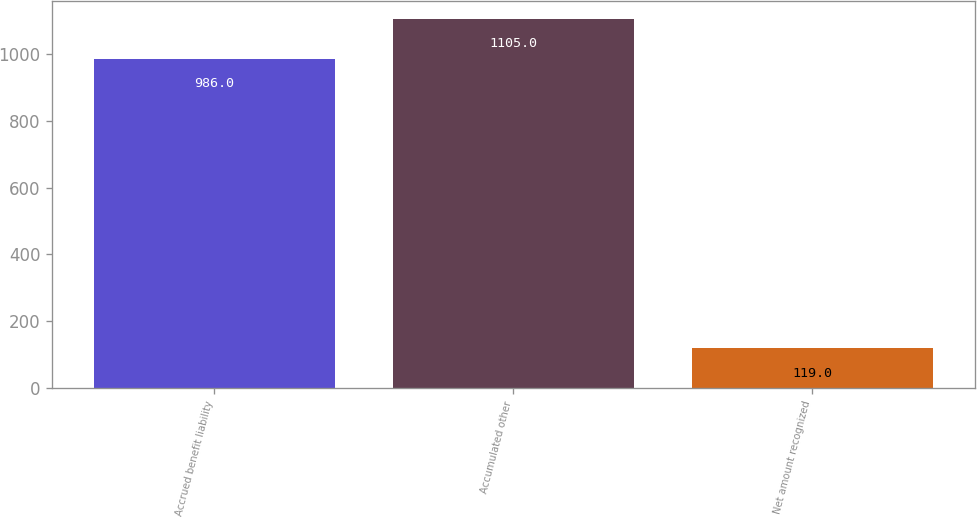Convert chart to OTSL. <chart><loc_0><loc_0><loc_500><loc_500><bar_chart><fcel>Accrued benefit liability<fcel>Accumulated other<fcel>Net amount recognized<nl><fcel>986<fcel>1105<fcel>119<nl></chart> 